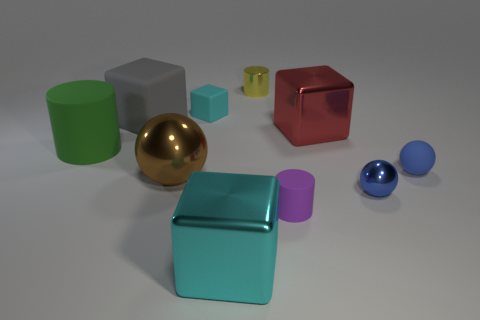Subtract all blue spheres. How many spheres are left? 1 Subtract all tiny purple cylinders. How many cylinders are left? 2 Subtract all blue cylinders. How many green cubes are left? 0 Add 1 tiny yellow things. How many tiny yellow things are left? 2 Add 3 large green things. How many large green things exist? 4 Subtract 1 gray cubes. How many objects are left? 9 Subtract all blocks. How many objects are left? 6 Subtract 2 cylinders. How many cylinders are left? 1 Subtract all green cubes. Subtract all red spheres. How many cubes are left? 4 Subtract all big brown metal things. Subtract all tiny green metallic cylinders. How many objects are left? 9 